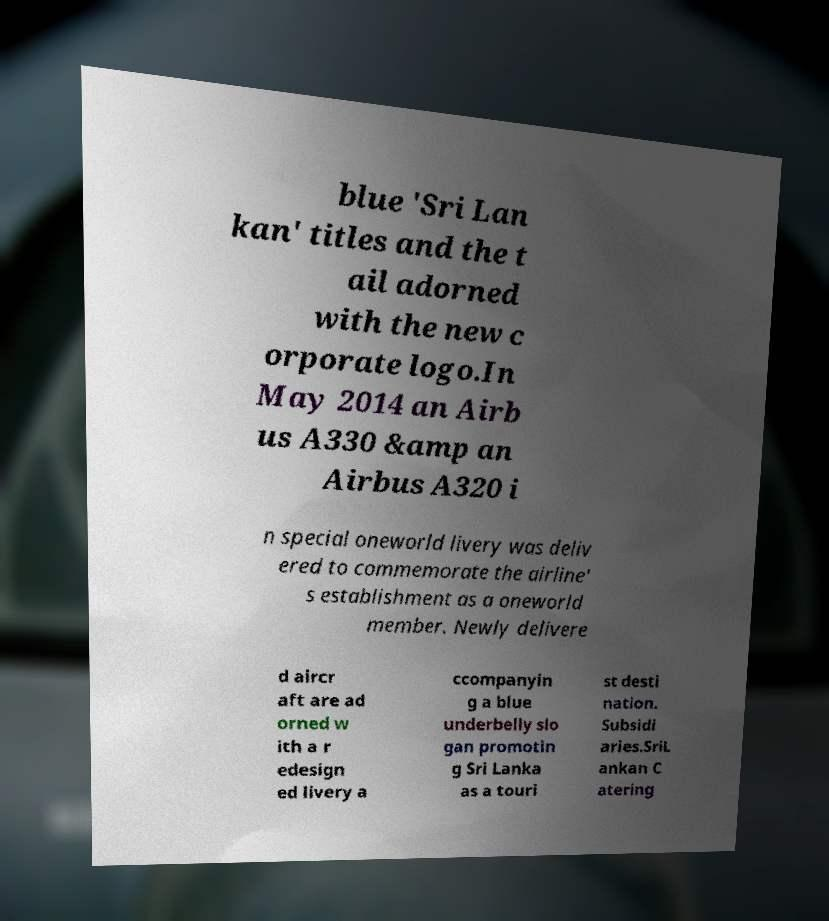Could you assist in decoding the text presented in this image and type it out clearly? blue 'Sri Lan kan' titles and the t ail adorned with the new c orporate logo.In May 2014 an Airb us A330 &amp an Airbus A320 i n special oneworld livery was deliv ered to commemorate the airline' s establishment as a oneworld member. Newly delivere d aircr aft are ad orned w ith a r edesign ed livery a ccompanyin g a blue underbelly slo gan promotin g Sri Lanka as a touri st desti nation. Subsidi aries.SriL ankan C atering 